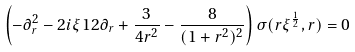<formula> <loc_0><loc_0><loc_500><loc_500>\left ( - \partial _ { r } ^ { 2 } - 2 i \xi ^ { } { 1 } 2 \partial _ { r } + \frac { 3 } { 4 r ^ { 2 } } - \frac { 8 } { ( 1 + r ^ { 2 } ) ^ { 2 } } \right ) \sigma ( r \xi ^ { \frac { 1 } { 2 } } , r ) = 0</formula> 